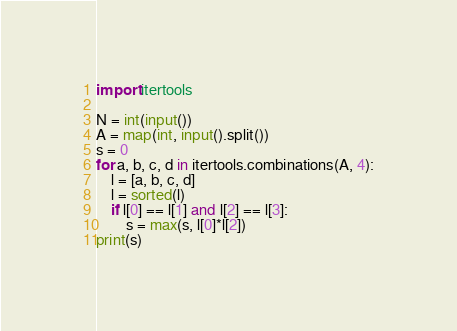Convert code to text. <code><loc_0><loc_0><loc_500><loc_500><_Python_>import itertools

N = int(input())
A = map(int, input().split())
s = 0
for a, b, c, d in itertools.combinations(A, 4):
    l = [a, b, c, d]
    l = sorted(l)
    if l[0] == l[1] and l[2] == l[3]:
        s = max(s, l[0]*l[2])
print(s)</code> 